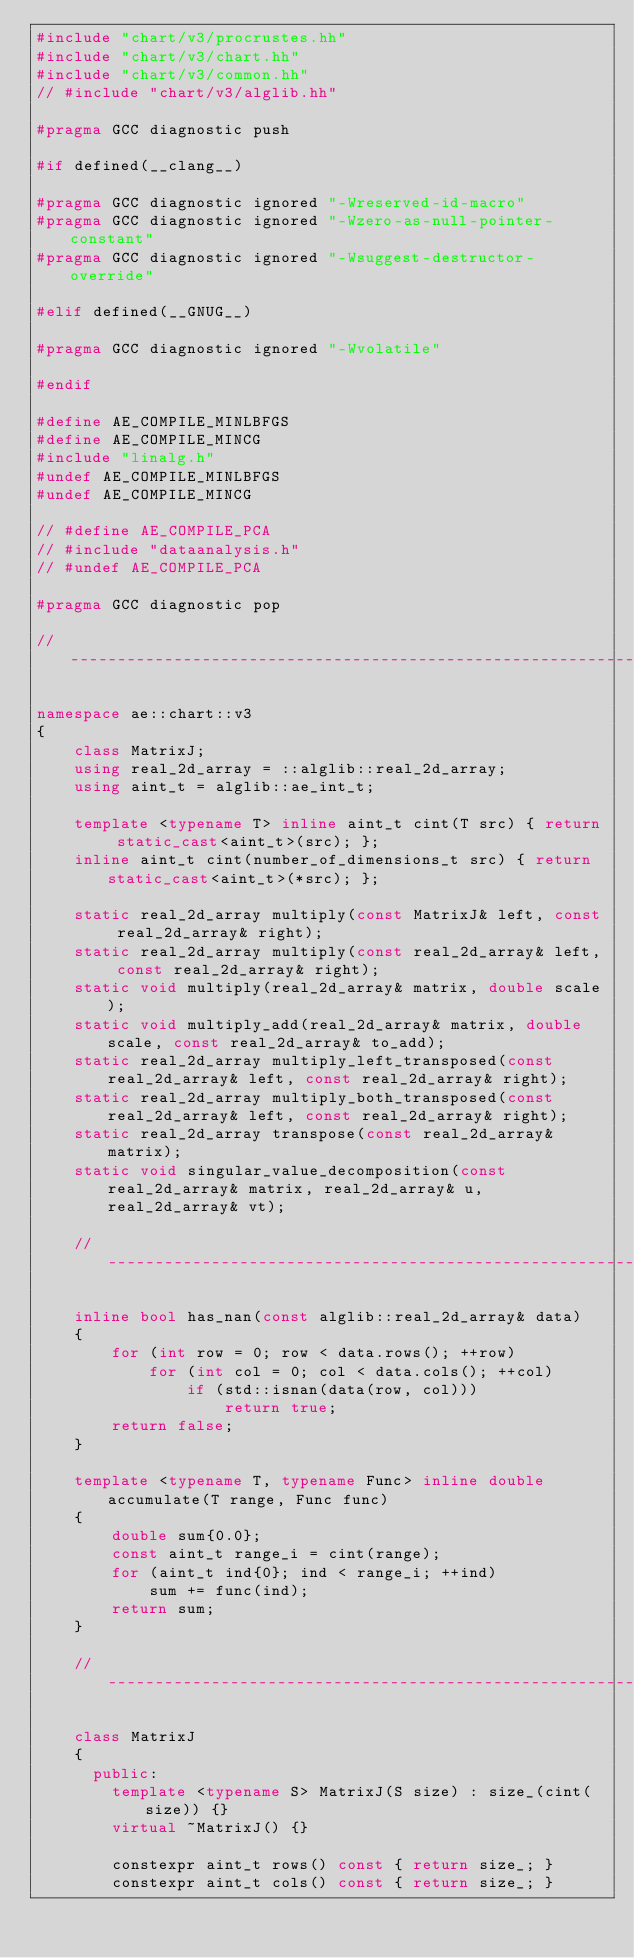<code> <loc_0><loc_0><loc_500><loc_500><_C++_>#include "chart/v3/procrustes.hh"
#include "chart/v3/chart.hh"
#include "chart/v3/common.hh"
// #include "chart/v3/alglib.hh"

#pragma GCC diagnostic push

#if defined(__clang__)

#pragma GCC diagnostic ignored "-Wreserved-id-macro"
#pragma GCC diagnostic ignored "-Wzero-as-null-pointer-constant"
#pragma GCC diagnostic ignored "-Wsuggest-destructor-override"

#elif defined(__GNUG__)

#pragma GCC diagnostic ignored "-Wvolatile"

#endif

#define AE_COMPILE_MINLBFGS
#define AE_COMPILE_MINCG
#include "linalg.h"
#undef AE_COMPILE_MINLBFGS
#undef AE_COMPILE_MINCG

// #define AE_COMPILE_PCA
// #include "dataanalysis.h"
// #undef AE_COMPILE_PCA

#pragma GCC diagnostic pop

// ----------------------------------------------------------------------

namespace ae::chart::v3
{
    class MatrixJ;
    using real_2d_array = ::alglib::real_2d_array;
    using aint_t = alglib::ae_int_t;

    template <typename T> inline aint_t cint(T src) { return static_cast<aint_t>(src); };
    inline aint_t cint(number_of_dimensions_t src) { return static_cast<aint_t>(*src); };

    static real_2d_array multiply(const MatrixJ& left, const real_2d_array& right);
    static real_2d_array multiply(const real_2d_array& left, const real_2d_array& right);
    static void multiply(real_2d_array& matrix, double scale);
    static void multiply_add(real_2d_array& matrix, double scale, const real_2d_array& to_add);
    static real_2d_array multiply_left_transposed(const real_2d_array& left, const real_2d_array& right);
    static real_2d_array multiply_both_transposed(const real_2d_array& left, const real_2d_array& right);
    static real_2d_array transpose(const real_2d_array& matrix);
    static void singular_value_decomposition(const real_2d_array& matrix, real_2d_array& u, real_2d_array& vt);

    // ----------------------------------------------------------------------

    inline bool has_nan(const alglib::real_2d_array& data)
    {
        for (int row = 0; row < data.rows(); ++row)
            for (int col = 0; col < data.cols(); ++col)
                if (std::isnan(data(row, col)))
                    return true;
        return false;
    }

    template <typename T, typename Func> inline double accumulate(T range, Func func)
    {
        double sum{0.0};
        const aint_t range_i = cint(range);
        for (aint_t ind{0}; ind < range_i; ++ind)
            sum += func(ind);
        return sum;
    }

    // ----------------------------------------------------------------------

    class MatrixJ
    {
      public:
        template <typename S> MatrixJ(S size) : size_(cint(size)) {}
        virtual ~MatrixJ() {}

        constexpr aint_t rows() const { return size_; }
        constexpr aint_t cols() const { return size_; }</code> 